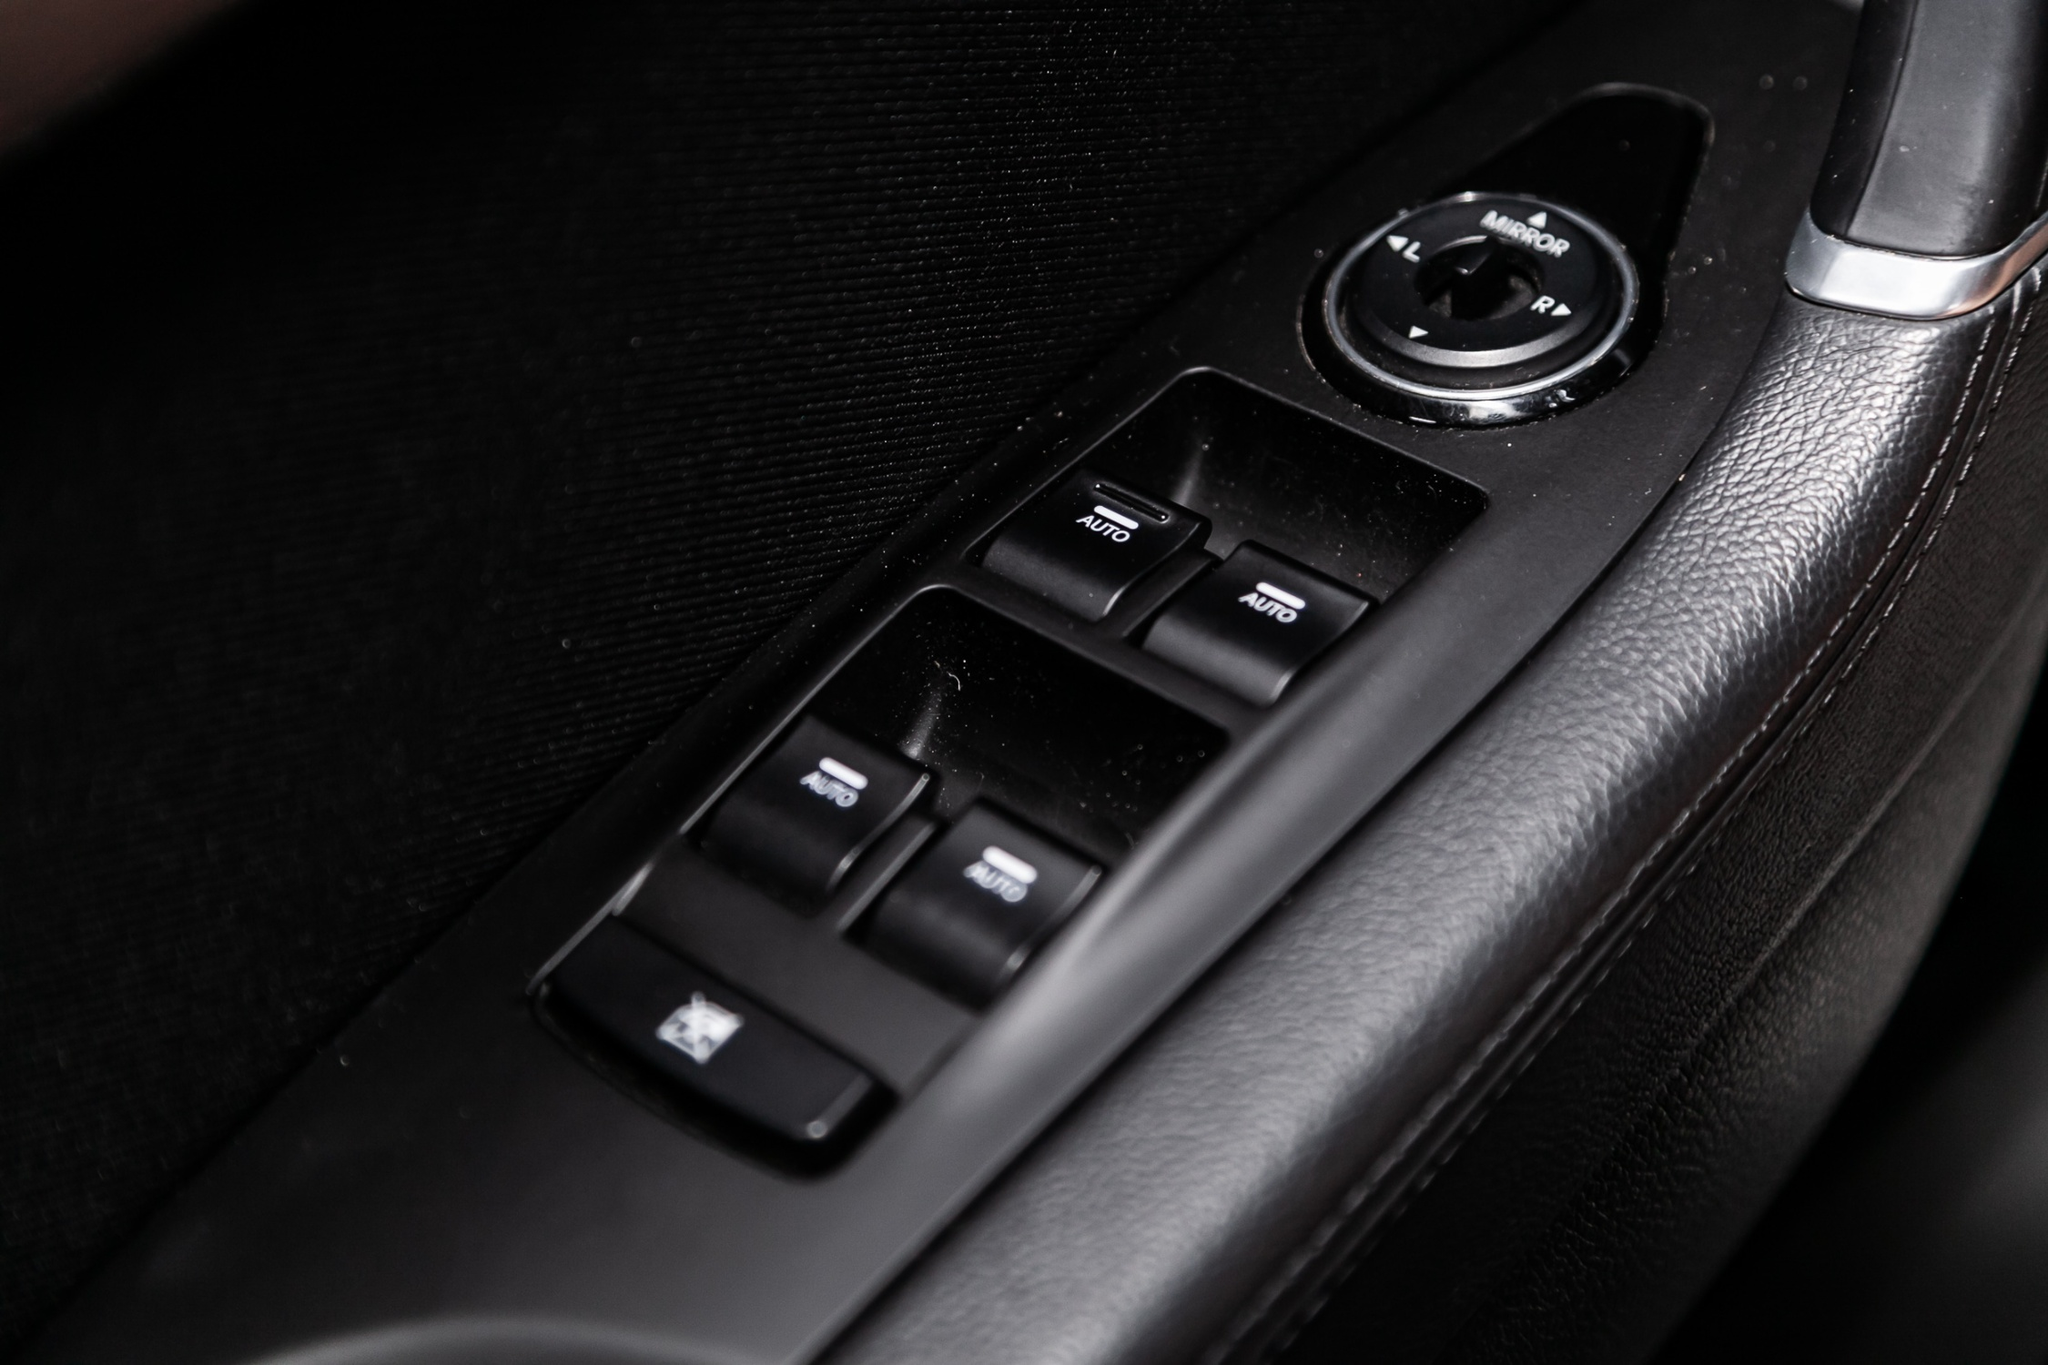Describe an unexpected scenario involving the driver's side door of this car. One stormy evening, the driver, Emma, finds herself stuck in a heavy downpour. She reaches for the window AUTO button to close the window she had slightly opened for fresh air. As she presses the button, a sudden flash of lightning strikes a nearby tree, causing a massive branch to fall towards her car. Just in time, she presses the PWR button, activating the reinforced power lock system, and the branch hits the side harmlessly, the car's structure absorbing the impact. Shaken but unharmed, Emma is grateful for the quick responsive design of the control panel that ensured her safety in an unexpected and perilous situation.  Can you describe a more everyday use of the driver's side door controls? On a typical morning, John hops into his car, ready to drive to work. He adjusts the side mirror using the circular knob to get the perfect angle. As he starts the car, he presses the 'AUTO' button to lower the driver's side window slightly for some fresh air. Remembering he has to pick up a friend, he presses the lock button to unlock all doors simultaneously. Throughout his drive, the ease and intuitiveness of the controls make his journey smooth and comfortable, highlighting the thoughtful design of the driver's side door. 